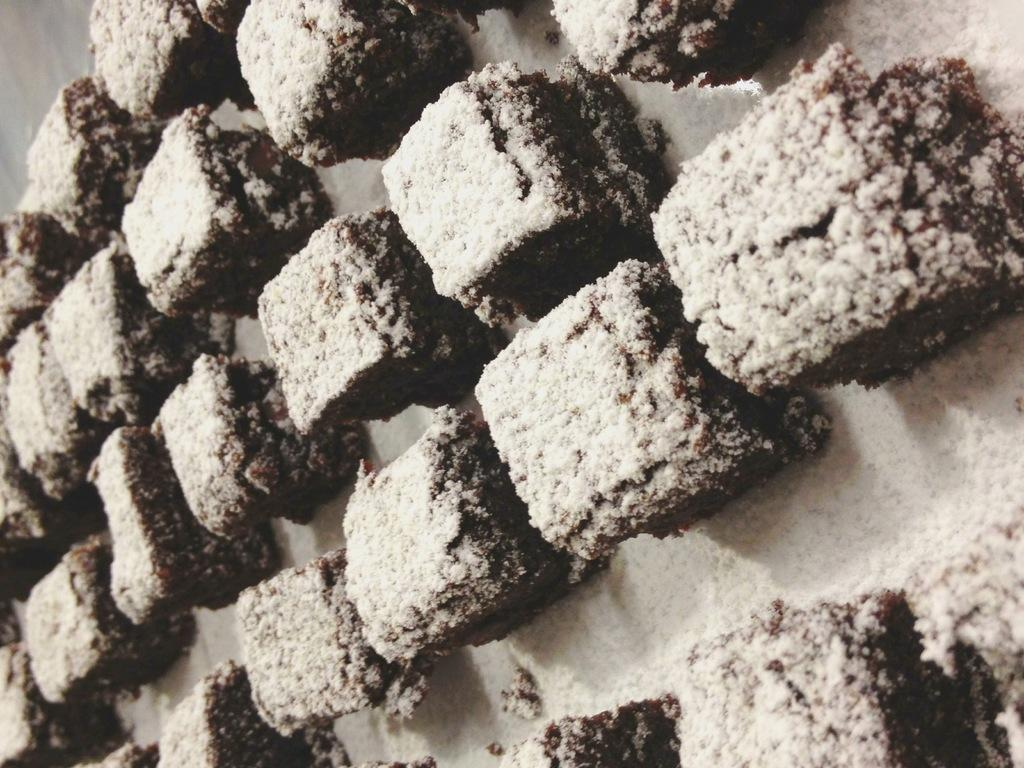What type of dessert is featured in the image? The image contains chocolate brownies. What is the average income of the people who made the brownies in the image? There is no information about the income of the people who made the brownies in the image, nor is there any indication that the brownies were made by people. 